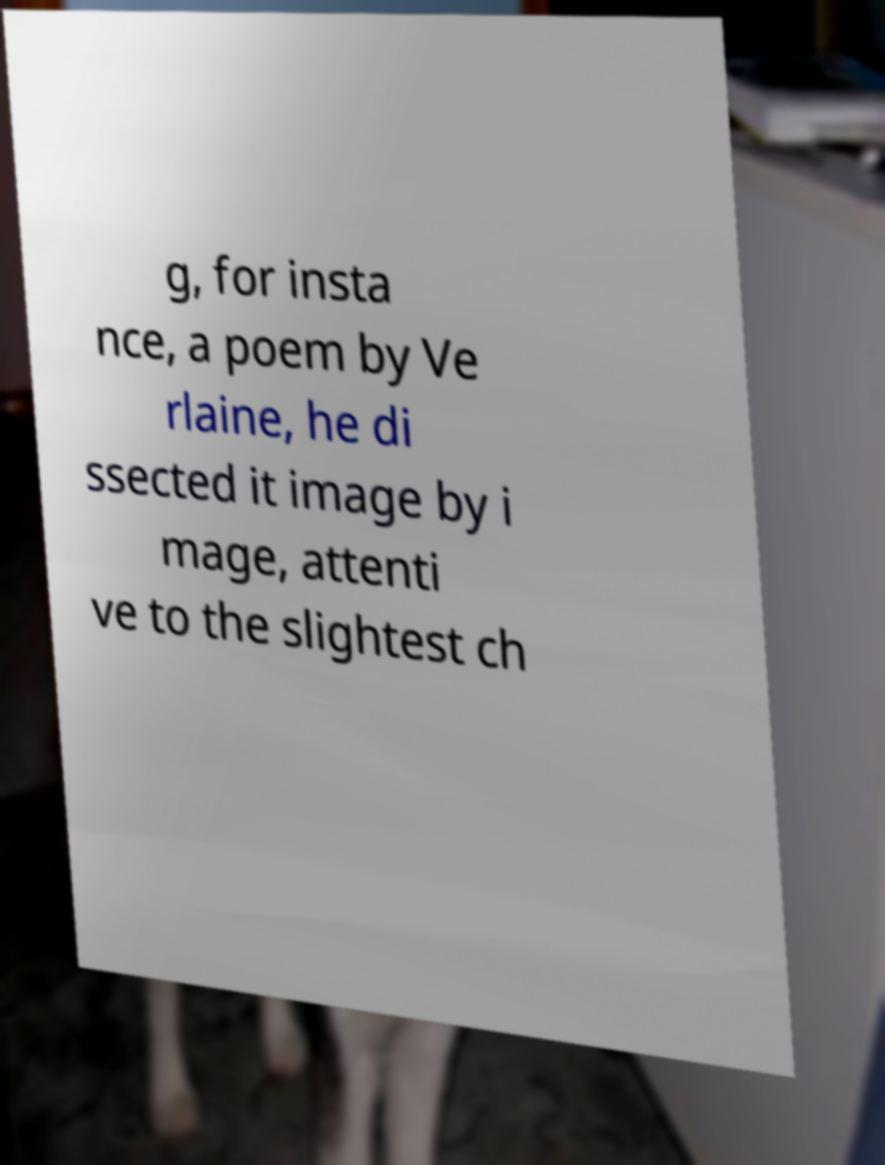Please identify and transcribe the text found in this image. g, for insta nce, a poem by Ve rlaine, he di ssected it image by i mage, attenti ve to the slightest ch 